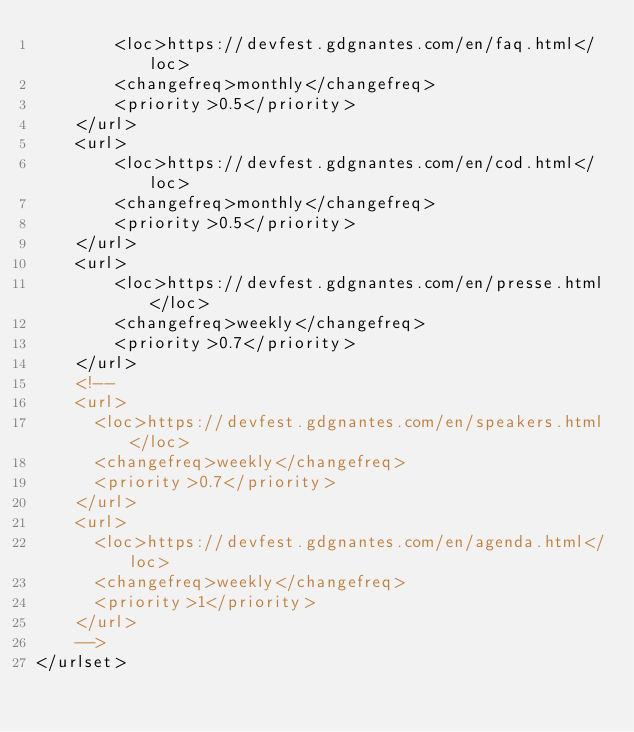<code> <loc_0><loc_0><loc_500><loc_500><_XML_>        <loc>https://devfest.gdgnantes.com/en/faq.html</loc>
        <changefreq>monthly</changefreq>
        <priority>0.5</priority>
    </url>
    <url>
        <loc>https://devfest.gdgnantes.com/en/cod.html</loc>
        <changefreq>monthly</changefreq>
        <priority>0.5</priority>
    </url>
    <url>
        <loc>https://devfest.gdgnantes.com/en/presse.html</loc>
        <changefreq>weekly</changefreq>
        <priority>0.7</priority>
    </url>
    <!--
    <url>
      <loc>https://devfest.gdgnantes.com/en/speakers.html</loc>
      <changefreq>weekly</changefreq>
      <priority>0.7</priority>
    </url>
    <url>
      <loc>https://devfest.gdgnantes.com/en/agenda.html</loc>
      <changefreq>weekly</changefreq>
      <priority>1</priority>
    </url>
    -->
</urlset>
</code> 